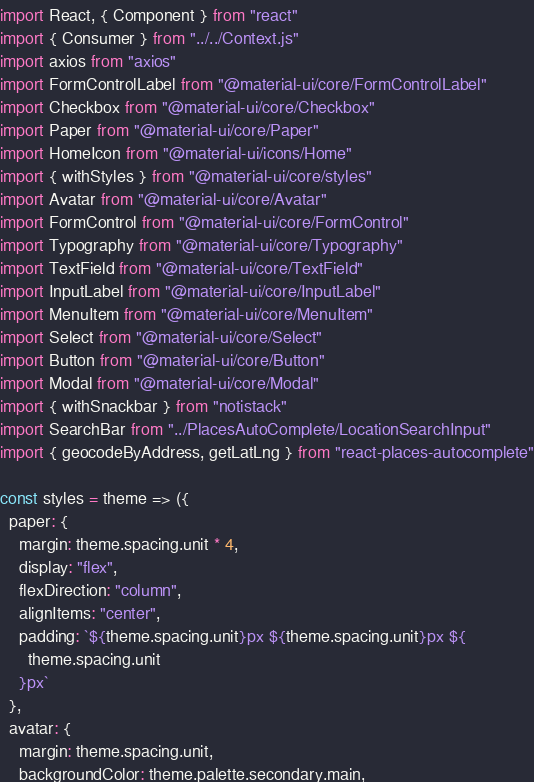<code> <loc_0><loc_0><loc_500><loc_500><_JavaScript_>import React, { Component } from "react"
import { Consumer } from "../../Context.js"
import axios from "axios"
import FormControlLabel from "@material-ui/core/FormControlLabel"
import Checkbox from "@material-ui/core/Checkbox"
import Paper from "@material-ui/core/Paper"
import HomeIcon from "@material-ui/icons/Home"
import { withStyles } from "@material-ui/core/styles"
import Avatar from "@material-ui/core/Avatar"
import FormControl from "@material-ui/core/FormControl"
import Typography from "@material-ui/core/Typography"
import TextField from "@material-ui/core/TextField"
import InputLabel from "@material-ui/core/InputLabel"
import MenuItem from "@material-ui/core/MenuItem"
import Select from "@material-ui/core/Select"
import Button from "@material-ui/core/Button"
import Modal from "@material-ui/core/Modal"
import { withSnackbar } from "notistack"
import SearchBar from "../PlacesAutoComplete/LocationSearchInput"
import { geocodeByAddress, getLatLng } from "react-places-autocomplete"

const styles = theme => ({
  paper: {
    margin: theme.spacing.unit * 4,
    display: "flex",
    flexDirection: "column",
    alignItems: "center",
    padding: `${theme.spacing.unit}px ${theme.spacing.unit}px ${
      theme.spacing.unit
    }px`
  },
  avatar: {
    margin: theme.spacing.unit,
    backgroundColor: theme.palette.secondary.main,</code> 